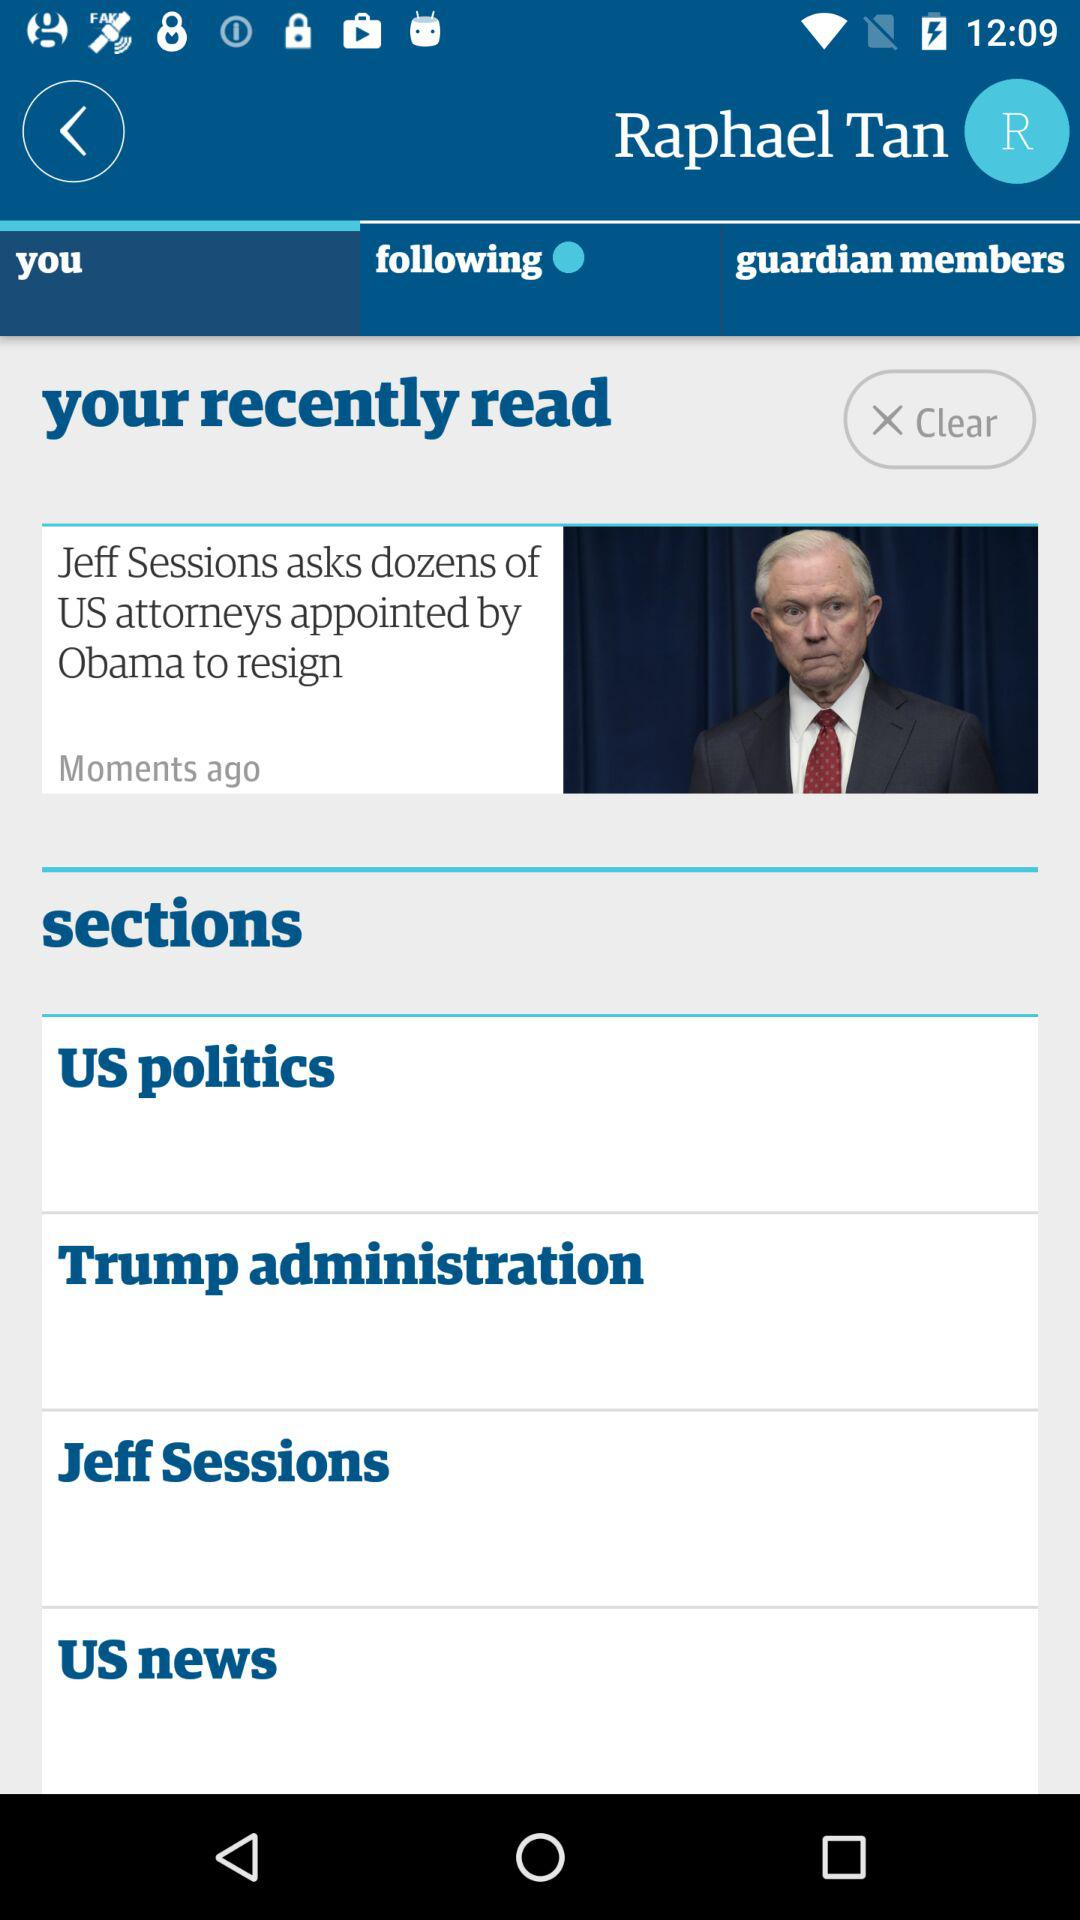What news did I recently read? The news you recently read was "Jeff Sessions asks dozens of US attorneys appointed by Obama to resign". 